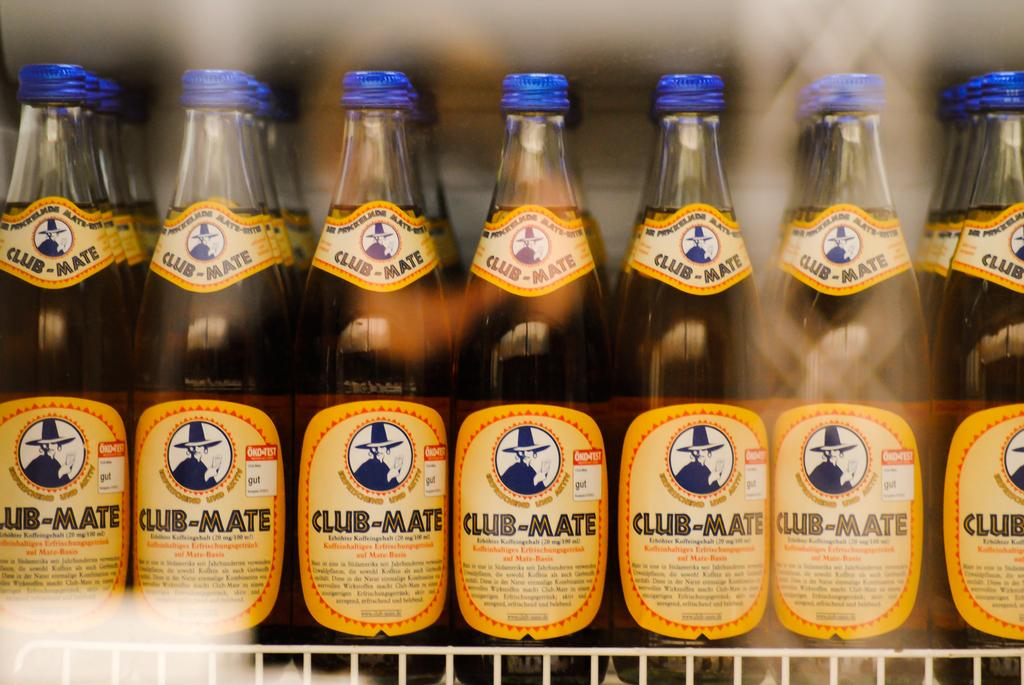Provide a one-sentence caption for the provided image. The image is of a horizontal row of bottles with the label saying "club mate.". 